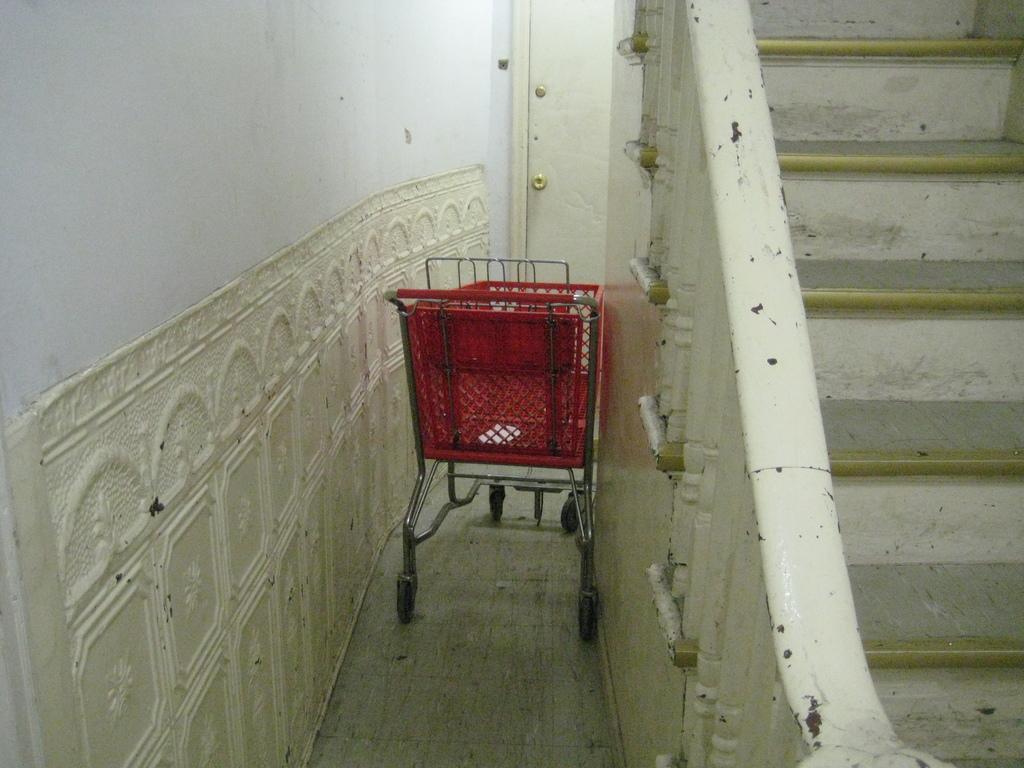Please provide a concise description of this image. In this image, we can see a shopping cart in between walls. There is a staircase on the right side of the image. 